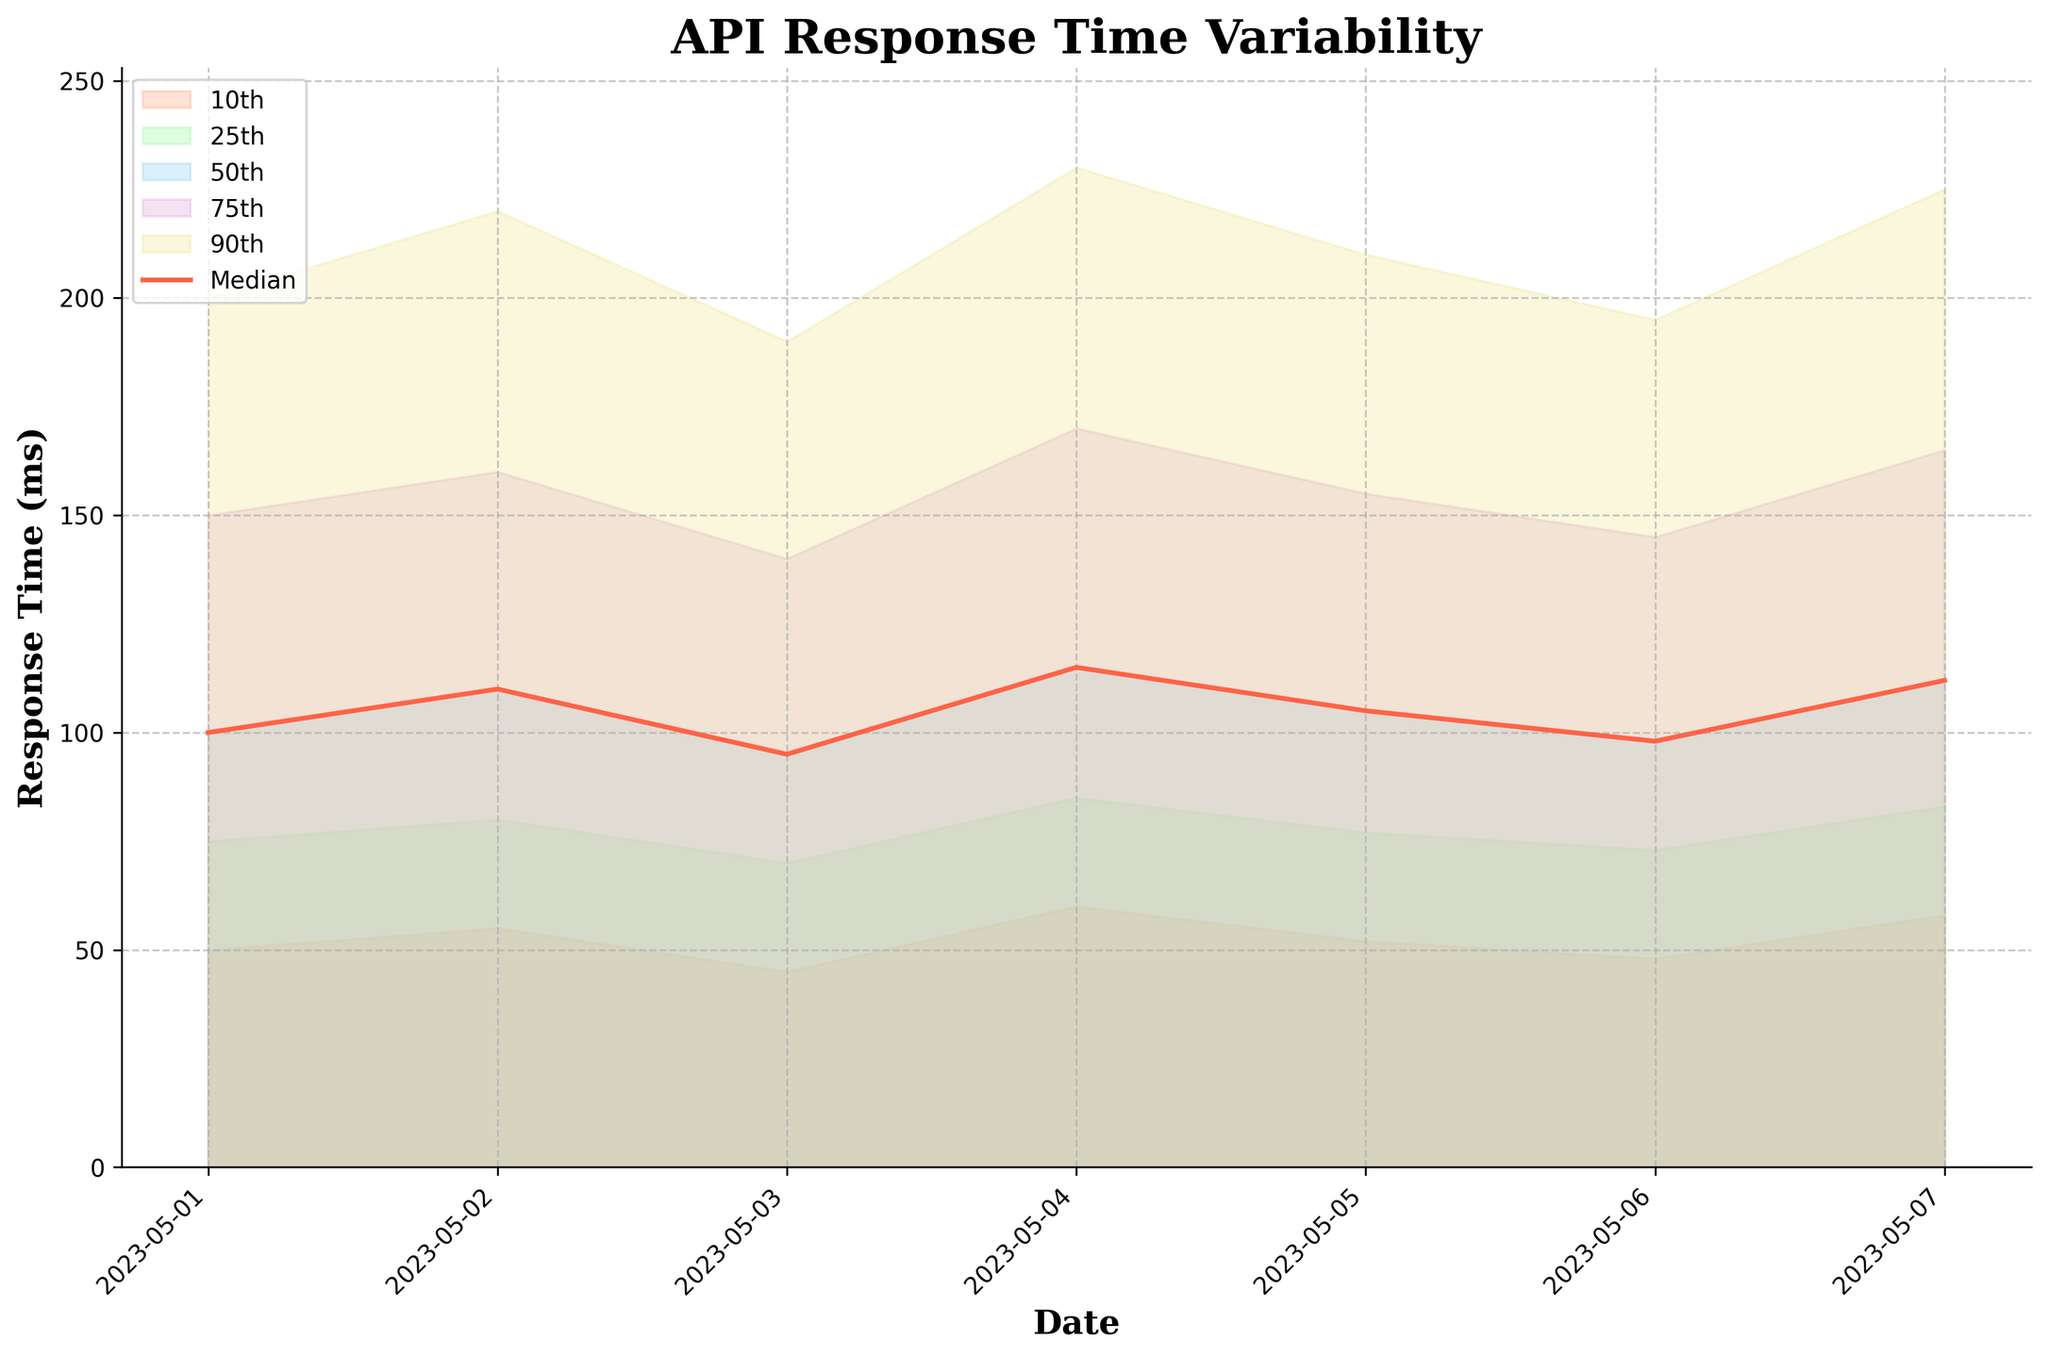What's the title of the figure? The title of the figure is prominently displayed at the top and is clearly labeled "API Response Time Variability".
Answer: API Response Time Variability What is the median API response time on May 5th? Look at the P50 line (red line) above May 5th. The value is listed as 105 ms.
Answer: 105 ms How many data points are represented on the x-axis? Look at the x-axis of the plot, which represents dates from May 1st to 7th. Thus, there are seven data points.
Answer: 7 Which day has the highest 90th percentile response time? The graph shows the highest P90 response time on May 4th, where the value is 230 ms.
Answer: May 4th What is the range of response times on May 2nd? On May 2nd, the lowest 10th percentile (P10) is 55 ms and the highest 90th percentile (P90) is 220 ms. The range is calculated as 220 - 55 = 165 ms.
Answer: 165 ms Which day shows the smallest variability in response times? Variability can be seen between the 10th percentile (P10) and 90th percentile (P90) values. The smallest difference is on May 3rd, calculated as 190 ms - 45 ms = 145 ms.
Answer: May 3rd Is there a noticeable trend in the median response times across the dates? Look at the P50 line (red line). The trend appears relatively stable with fluctuations but no large increasing or decreasing trend across the dates.
Answer: Stable with fluctuations On which day is the upper quartile (75th percentile) response time equal to 165 ms? Check the P75 section for which day it intersects at 165 ms. It intersects on May 7th.
Answer: May 7th How many colors are used to fill the percentiles? Each percentile area is filled with a distinct color, and there are five percentiles, each with a unique color.
Answer: 5 